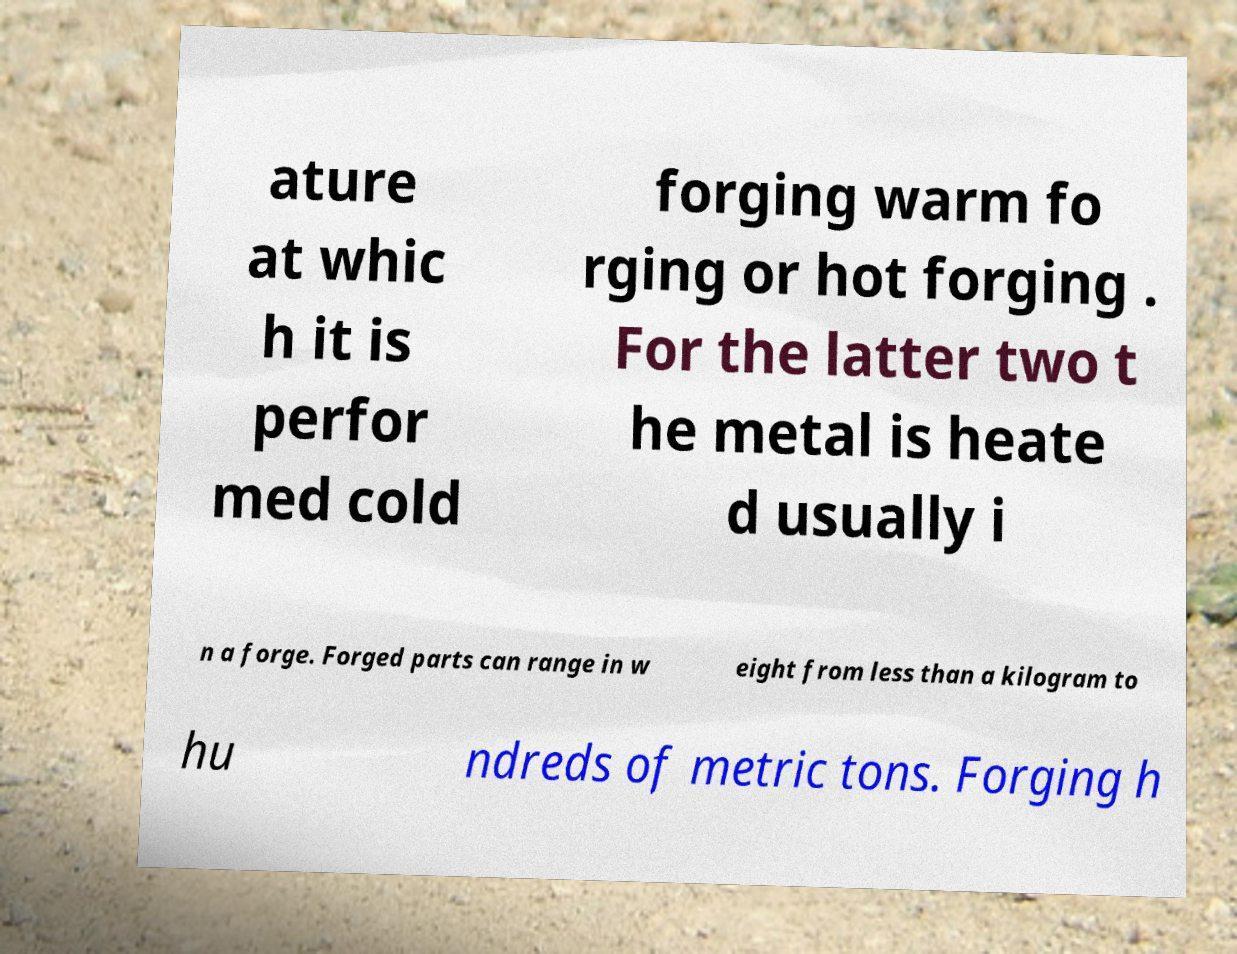Can you accurately transcribe the text from the provided image for me? ature at whic h it is perfor med cold forging warm fo rging or hot forging . For the latter two t he metal is heate d usually i n a forge. Forged parts can range in w eight from less than a kilogram to hu ndreds of metric tons. Forging h 